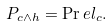Convert formula to latex. <formula><loc_0><loc_0><loc_500><loc_500>P _ { c \wedge h } = \Pr e l _ { c } .</formula> 